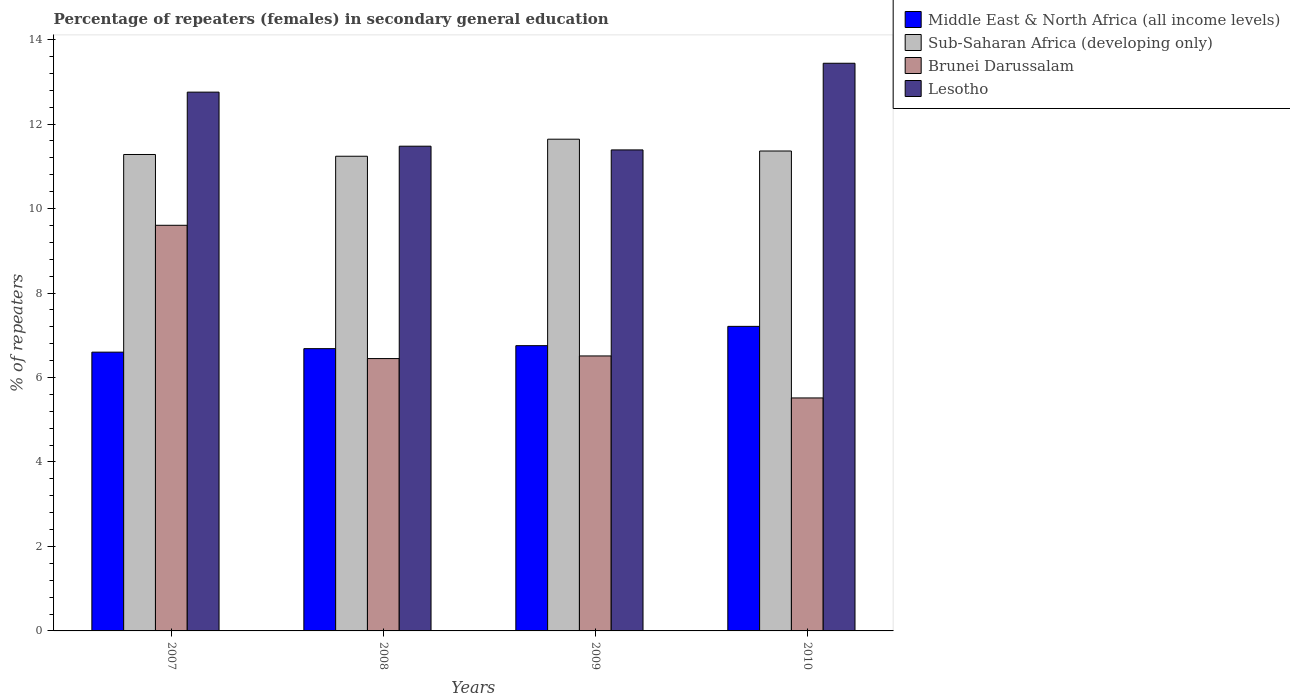How many different coloured bars are there?
Offer a terse response. 4. Are the number of bars per tick equal to the number of legend labels?
Provide a succinct answer. Yes. In how many cases, is the number of bars for a given year not equal to the number of legend labels?
Your answer should be very brief. 0. What is the percentage of female repeaters in Sub-Saharan Africa (developing only) in 2008?
Offer a terse response. 11.24. Across all years, what is the maximum percentage of female repeaters in Brunei Darussalam?
Offer a very short reply. 9.6. Across all years, what is the minimum percentage of female repeaters in Sub-Saharan Africa (developing only)?
Make the answer very short. 11.24. What is the total percentage of female repeaters in Lesotho in the graph?
Your answer should be very brief. 49.06. What is the difference between the percentage of female repeaters in Brunei Darussalam in 2008 and that in 2010?
Keep it short and to the point. 0.93. What is the difference between the percentage of female repeaters in Middle East & North Africa (all income levels) in 2008 and the percentage of female repeaters in Brunei Darussalam in 2010?
Your response must be concise. 1.17. What is the average percentage of female repeaters in Middle East & North Africa (all income levels) per year?
Make the answer very short. 6.81. In the year 2008, what is the difference between the percentage of female repeaters in Brunei Darussalam and percentage of female repeaters in Lesotho?
Give a very brief answer. -5.03. What is the ratio of the percentage of female repeaters in Sub-Saharan Africa (developing only) in 2007 to that in 2008?
Your response must be concise. 1. Is the difference between the percentage of female repeaters in Brunei Darussalam in 2008 and 2009 greater than the difference between the percentage of female repeaters in Lesotho in 2008 and 2009?
Offer a terse response. No. What is the difference between the highest and the second highest percentage of female repeaters in Middle East & North Africa (all income levels)?
Offer a terse response. 0.46. What is the difference between the highest and the lowest percentage of female repeaters in Middle East & North Africa (all income levels)?
Ensure brevity in your answer.  0.61. Is it the case that in every year, the sum of the percentage of female repeaters in Lesotho and percentage of female repeaters in Brunei Darussalam is greater than the sum of percentage of female repeaters in Middle East & North Africa (all income levels) and percentage of female repeaters in Sub-Saharan Africa (developing only)?
Offer a very short reply. No. What does the 3rd bar from the left in 2007 represents?
Offer a terse response. Brunei Darussalam. What does the 3rd bar from the right in 2007 represents?
Offer a very short reply. Sub-Saharan Africa (developing only). What is the difference between two consecutive major ticks on the Y-axis?
Provide a succinct answer. 2. Are the values on the major ticks of Y-axis written in scientific E-notation?
Keep it short and to the point. No. Does the graph contain any zero values?
Make the answer very short. No. Where does the legend appear in the graph?
Ensure brevity in your answer.  Top right. How many legend labels are there?
Keep it short and to the point. 4. What is the title of the graph?
Provide a short and direct response. Percentage of repeaters (females) in secondary general education. Does "India" appear as one of the legend labels in the graph?
Your response must be concise. No. What is the label or title of the X-axis?
Provide a succinct answer. Years. What is the label or title of the Y-axis?
Your answer should be very brief. % of repeaters. What is the % of repeaters of Middle East & North Africa (all income levels) in 2007?
Your response must be concise. 6.6. What is the % of repeaters in Sub-Saharan Africa (developing only) in 2007?
Your answer should be very brief. 11.28. What is the % of repeaters in Brunei Darussalam in 2007?
Your answer should be compact. 9.6. What is the % of repeaters of Lesotho in 2007?
Keep it short and to the point. 12.76. What is the % of repeaters in Middle East & North Africa (all income levels) in 2008?
Keep it short and to the point. 6.68. What is the % of repeaters of Sub-Saharan Africa (developing only) in 2008?
Provide a short and direct response. 11.24. What is the % of repeaters of Brunei Darussalam in 2008?
Keep it short and to the point. 6.45. What is the % of repeaters of Lesotho in 2008?
Give a very brief answer. 11.48. What is the % of repeaters of Middle East & North Africa (all income levels) in 2009?
Give a very brief answer. 6.75. What is the % of repeaters of Sub-Saharan Africa (developing only) in 2009?
Provide a succinct answer. 11.64. What is the % of repeaters in Brunei Darussalam in 2009?
Your response must be concise. 6.51. What is the % of repeaters in Lesotho in 2009?
Your answer should be very brief. 11.39. What is the % of repeaters of Middle East & North Africa (all income levels) in 2010?
Give a very brief answer. 7.21. What is the % of repeaters of Sub-Saharan Africa (developing only) in 2010?
Offer a very short reply. 11.36. What is the % of repeaters of Brunei Darussalam in 2010?
Your response must be concise. 5.52. What is the % of repeaters of Lesotho in 2010?
Provide a succinct answer. 13.44. Across all years, what is the maximum % of repeaters of Middle East & North Africa (all income levels)?
Ensure brevity in your answer.  7.21. Across all years, what is the maximum % of repeaters of Sub-Saharan Africa (developing only)?
Make the answer very short. 11.64. Across all years, what is the maximum % of repeaters of Brunei Darussalam?
Offer a terse response. 9.6. Across all years, what is the maximum % of repeaters in Lesotho?
Offer a very short reply. 13.44. Across all years, what is the minimum % of repeaters of Middle East & North Africa (all income levels)?
Give a very brief answer. 6.6. Across all years, what is the minimum % of repeaters of Sub-Saharan Africa (developing only)?
Provide a short and direct response. 11.24. Across all years, what is the minimum % of repeaters in Brunei Darussalam?
Provide a short and direct response. 5.52. Across all years, what is the minimum % of repeaters of Lesotho?
Your response must be concise. 11.39. What is the total % of repeaters in Middle East & North Africa (all income levels) in the graph?
Your answer should be compact. 27.25. What is the total % of repeaters in Sub-Saharan Africa (developing only) in the graph?
Provide a succinct answer. 45.52. What is the total % of repeaters of Brunei Darussalam in the graph?
Offer a terse response. 28.08. What is the total % of repeaters of Lesotho in the graph?
Ensure brevity in your answer.  49.06. What is the difference between the % of repeaters in Middle East & North Africa (all income levels) in 2007 and that in 2008?
Your response must be concise. -0.08. What is the difference between the % of repeaters in Sub-Saharan Africa (developing only) in 2007 and that in 2008?
Offer a terse response. 0.04. What is the difference between the % of repeaters in Brunei Darussalam in 2007 and that in 2008?
Give a very brief answer. 3.16. What is the difference between the % of repeaters of Lesotho in 2007 and that in 2008?
Provide a succinct answer. 1.28. What is the difference between the % of repeaters of Middle East & North Africa (all income levels) in 2007 and that in 2009?
Give a very brief answer. -0.15. What is the difference between the % of repeaters in Sub-Saharan Africa (developing only) in 2007 and that in 2009?
Offer a very short reply. -0.36. What is the difference between the % of repeaters of Brunei Darussalam in 2007 and that in 2009?
Offer a terse response. 3.09. What is the difference between the % of repeaters in Lesotho in 2007 and that in 2009?
Your response must be concise. 1.37. What is the difference between the % of repeaters of Middle East & North Africa (all income levels) in 2007 and that in 2010?
Your answer should be very brief. -0.61. What is the difference between the % of repeaters in Sub-Saharan Africa (developing only) in 2007 and that in 2010?
Offer a very short reply. -0.08. What is the difference between the % of repeaters in Brunei Darussalam in 2007 and that in 2010?
Keep it short and to the point. 4.09. What is the difference between the % of repeaters of Lesotho in 2007 and that in 2010?
Offer a very short reply. -0.68. What is the difference between the % of repeaters of Middle East & North Africa (all income levels) in 2008 and that in 2009?
Keep it short and to the point. -0.07. What is the difference between the % of repeaters of Sub-Saharan Africa (developing only) in 2008 and that in 2009?
Ensure brevity in your answer.  -0.4. What is the difference between the % of repeaters in Brunei Darussalam in 2008 and that in 2009?
Keep it short and to the point. -0.06. What is the difference between the % of repeaters of Lesotho in 2008 and that in 2009?
Make the answer very short. 0.09. What is the difference between the % of repeaters of Middle East & North Africa (all income levels) in 2008 and that in 2010?
Make the answer very short. -0.53. What is the difference between the % of repeaters of Sub-Saharan Africa (developing only) in 2008 and that in 2010?
Provide a succinct answer. -0.12. What is the difference between the % of repeaters of Brunei Darussalam in 2008 and that in 2010?
Provide a succinct answer. 0.93. What is the difference between the % of repeaters in Lesotho in 2008 and that in 2010?
Give a very brief answer. -1.96. What is the difference between the % of repeaters in Middle East & North Africa (all income levels) in 2009 and that in 2010?
Your response must be concise. -0.46. What is the difference between the % of repeaters in Sub-Saharan Africa (developing only) in 2009 and that in 2010?
Your answer should be compact. 0.28. What is the difference between the % of repeaters of Brunei Darussalam in 2009 and that in 2010?
Keep it short and to the point. 0.99. What is the difference between the % of repeaters in Lesotho in 2009 and that in 2010?
Your answer should be compact. -2.05. What is the difference between the % of repeaters of Middle East & North Africa (all income levels) in 2007 and the % of repeaters of Sub-Saharan Africa (developing only) in 2008?
Ensure brevity in your answer.  -4.64. What is the difference between the % of repeaters in Middle East & North Africa (all income levels) in 2007 and the % of repeaters in Brunei Darussalam in 2008?
Your response must be concise. 0.15. What is the difference between the % of repeaters in Middle East & North Africa (all income levels) in 2007 and the % of repeaters in Lesotho in 2008?
Offer a very short reply. -4.88. What is the difference between the % of repeaters of Sub-Saharan Africa (developing only) in 2007 and the % of repeaters of Brunei Darussalam in 2008?
Your answer should be very brief. 4.83. What is the difference between the % of repeaters of Sub-Saharan Africa (developing only) in 2007 and the % of repeaters of Lesotho in 2008?
Keep it short and to the point. -0.2. What is the difference between the % of repeaters of Brunei Darussalam in 2007 and the % of repeaters of Lesotho in 2008?
Offer a very short reply. -1.87. What is the difference between the % of repeaters of Middle East & North Africa (all income levels) in 2007 and the % of repeaters of Sub-Saharan Africa (developing only) in 2009?
Ensure brevity in your answer.  -5.04. What is the difference between the % of repeaters in Middle East & North Africa (all income levels) in 2007 and the % of repeaters in Brunei Darussalam in 2009?
Your answer should be very brief. 0.09. What is the difference between the % of repeaters of Middle East & North Africa (all income levels) in 2007 and the % of repeaters of Lesotho in 2009?
Provide a short and direct response. -4.79. What is the difference between the % of repeaters of Sub-Saharan Africa (developing only) in 2007 and the % of repeaters of Brunei Darussalam in 2009?
Your answer should be compact. 4.77. What is the difference between the % of repeaters of Sub-Saharan Africa (developing only) in 2007 and the % of repeaters of Lesotho in 2009?
Provide a short and direct response. -0.11. What is the difference between the % of repeaters of Brunei Darussalam in 2007 and the % of repeaters of Lesotho in 2009?
Your response must be concise. -1.78. What is the difference between the % of repeaters in Middle East & North Africa (all income levels) in 2007 and the % of repeaters in Sub-Saharan Africa (developing only) in 2010?
Your answer should be compact. -4.76. What is the difference between the % of repeaters in Middle East & North Africa (all income levels) in 2007 and the % of repeaters in Brunei Darussalam in 2010?
Give a very brief answer. 1.08. What is the difference between the % of repeaters of Middle East & North Africa (all income levels) in 2007 and the % of repeaters of Lesotho in 2010?
Make the answer very short. -6.84. What is the difference between the % of repeaters in Sub-Saharan Africa (developing only) in 2007 and the % of repeaters in Brunei Darussalam in 2010?
Keep it short and to the point. 5.76. What is the difference between the % of repeaters of Sub-Saharan Africa (developing only) in 2007 and the % of repeaters of Lesotho in 2010?
Give a very brief answer. -2.16. What is the difference between the % of repeaters in Brunei Darussalam in 2007 and the % of repeaters in Lesotho in 2010?
Your answer should be very brief. -3.84. What is the difference between the % of repeaters of Middle East & North Africa (all income levels) in 2008 and the % of repeaters of Sub-Saharan Africa (developing only) in 2009?
Offer a very short reply. -4.96. What is the difference between the % of repeaters of Middle East & North Africa (all income levels) in 2008 and the % of repeaters of Brunei Darussalam in 2009?
Your answer should be compact. 0.17. What is the difference between the % of repeaters in Middle East & North Africa (all income levels) in 2008 and the % of repeaters in Lesotho in 2009?
Provide a succinct answer. -4.71. What is the difference between the % of repeaters in Sub-Saharan Africa (developing only) in 2008 and the % of repeaters in Brunei Darussalam in 2009?
Provide a succinct answer. 4.73. What is the difference between the % of repeaters of Sub-Saharan Africa (developing only) in 2008 and the % of repeaters of Lesotho in 2009?
Provide a short and direct response. -0.15. What is the difference between the % of repeaters of Brunei Darussalam in 2008 and the % of repeaters of Lesotho in 2009?
Your answer should be compact. -4.94. What is the difference between the % of repeaters in Middle East & North Africa (all income levels) in 2008 and the % of repeaters in Sub-Saharan Africa (developing only) in 2010?
Your answer should be very brief. -4.68. What is the difference between the % of repeaters in Middle East & North Africa (all income levels) in 2008 and the % of repeaters in Brunei Darussalam in 2010?
Offer a very short reply. 1.17. What is the difference between the % of repeaters in Middle East & North Africa (all income levels) in 2008 and the % of repeaters in Lesotho in 2010?
Ensure brevity in your answer.  -6.76. What is the difference between the % of repeaters of Sub-Saharan Africa (developing only) in 2008 and the % of repeaters of Brunei Darussalam in 2010?
Your response must be concise. 5.72. What is the difference between the % of repeaters of Sub-Saharan Africa (developing only) in 2008 and the % of repeaters of Lesotho in 2010?
Make the answer very short. -2.2. What is the difference between the % of repeaters in Brunei Darussalam in 2008 and the % of repeaters in Lesotho in 2010?
Make the answer very short. -6.99. What is the difference between the % of repeaters of Middle East & North Africa (all income levels) in 2009 and the % of repeaters of Sub-Saharan Africa (developing only) in 2010?
Provide a succinct answer. -4.61. What is the difference between the % of repeaters in Middle East & North Africa (all income levels) in 2009 and the % of repeaters in Brunei Darussalam in 2010?
Make the answer very short. 1.24. What is the difference between the % of repeaters of Middle East & North Africa (all income levels) in 2009 and the % of repeaters of Lesotho in 2010?
Ensure brevity in your answer.  -6.69. What is the difference between the % of repeaters in Sub-Saharan Africa (developing only) in 2009 and the % of repeaters in Brunei Darussalam in 2010?
Your answer should be compact. 6.13. What is the difference between the % of repeaters in Sub-Saharan Africa (developing only) in 2009 and the % of repeaters in Lesotho in 2010?
Provide a short and direct response. -1.8. What is the difference between the % of repeaters of Brunei Darussalam in 2009 and the % of repeaters of Lesotho in 2010?
Provide a succinct answer. -6.93. What is the average % of repeaters of Middle East & North Africa (all income levels) per year?
Make the answer very short. 6.81. What is the average % of repeaters of Sub-Saharan Africa (developing only) per year?
Make the answer very short. 11.38. What is the average % of repeaters of Brunei Darussalam per year?
Provide a succinct answer. 7.02. What is the average % of repeaters in Lesotho per year?
Give a very brief answer. 12.27. In the year 2007, what is the difference between the % of repeaters of Middle East & North Africa (all income levels) and % of repeaters of Sub-Saharan Africa (developing only)?
Your response must be concise. -4.68. In the year 2007, what is the difference between the % of repeaters of Middle East & North Africa (all income levels) and % of repeaters of Brunei Darussalam?
Offer a terse response. -3. In the year 2007, what is the difference between the % of repeaters of Middle East & North Africa (all income levels) and % of repeaters of Lesotho?
Offer a very short reply. -6.16. In the year 2007, what is the difference between the % of repeaters of Sub-Saharan Africa (developing only) and % of repeaters of Brunei Darussalam?
Make the answer very short. 1.68. In the year 2007, what is the difference between the % of repeaters in Sub-Saharan Africa (developing only) and % of repeaters in Lesotho?
Your answer should be compact. -1.48. In the year 2007, what is the difference between the % of repeaters of Brunei Darussalam and % of repeaters of Lesotho?
Provide a short and direct response. -3.15. In the year 2008, what is the difference between the % of repeaters of Middle East & North Africa (all income levels) and % of repeaters of Sub-Saharan Africa (developing only)?
Ensure brevity in your answer.  -4.56. In the year 2008, what is the difference between the % of repeaters in Middle East & North Africa (all income levels) and % of repeaters in Brunei Darussalam?
Provide a succinct answer. 0.23. In the year 2008, what is the difference between the % of repeaters in Middle East & North Africa (all income levels) and % of repeaters in Lesotho?
Your answer should be very brief. -4.79. In the year 2008, what is the difference between the % of repeaters in Sub-Saharan Africa (developing only) and % of repeaters in Brunei Darussalam?
Offer a terse response. 4.79. In the year 2008, what is the difference between the % of repeaters in Sub-Saharan Africa (developing only) and % of repeaters in Lesotho?
Provide a succinct answer. -0.24. In the year 2008, what is the difference between the % of repeaters in Brunei Darussalam and % of repeaters in Lesotho?
Provide a succinct answer. -5.03. In the year 2009, what is the difference between the % of repeaters in Middle East & North Africa (all income levels) and % of repeaters in Sub-Saharan Africa (developing only)?
Keep it short and to the point. -4.89. In the year 2009, what is the difference between the % of repeaters of Middle East & North Africa (all income levels) and % of repeaters of Brunei Darussalam?
Your answer should be compact. 0.24. In the year 2009, what is the difference between the % of repeaters of Middle East & North Africa (all income levels) and % of repeaters of Lesotho?
Your answer should be very brief. -4.63. In the year 2009, what is the difference between the % of repeaters in Sub-Saharan Africa (developing only) and % of repeaters in Brunei Darussalam?
Your answer should be compact. 5.13. In the year 2009, what is the difference between the % of repeaters in Sub-Saharan Africa (developing only) and % of repeaters in Lesotho?
Your answer should be compact. 0.25. In the year 2009, what is the difference between the % of repeaters of Brunei Darussalam and % of repeaters of Lesotho?
Your response must be concise. -4.88. In the year 2010, what is the difference between the % of repeaters in Middle East & North Africa (all income levels) and % of repeaters in Sub-Saharan Africa (developing only)?
Give a very brief answer. -4.15. In the year 2010, what is the difference between the % of repeaters in Middle East & North Africa (all income levels) and % of repeaters in Brunei Darussalam?
Your response must be concise. 1.69. In the year 2010, what is the difference between the % of repeaters in Middle East & North Africa (all income levels) and % of repeaters in Lesotho?
Provide a succinct answer. -6.23. In the year 2010, what is the difference between the % of repeaters of Sub-Saharan Africa (developing only) and % of repeaters of Brunei Darussalam?
Make the answer very short. 5.85. In the year 2010, what is the difference between the % of repeaters in Sub-Saharan Africa (developing only) and % of repeaters in Lesotho?
Your answer should be compact. -2.08. In the year 2010, what is the difference between the % of repeaters in Brunei Darussalam and % of repeaters in Lesotho?
Provide a short and direct response. -7.92. What is the ratio of the % of repeaters of Middle East & North Africa (all income levels) in 2007 to that in 2008?
Offer a very short reply. 0.99. What is the ratio of the % of repeaters of Brunei Darussalam in 2007 to that in 2008?
Give a very brief answer. 1.49. What is the ratio of the % of repeaters of Lesotho in 2007 to that in 2008?
Your response must be concise. 1.11. What is the ratio of the % of repeaters in Middle East & North Africa (all income levels) in 2007 to that in 2009?
Keep it short and to the point. 0.98. What is the ratio of the % of repeaters in Sub-Saharan Africa (developing only) in 2007 to that in 2009?
Your answer should be compact. 0.97. What is the ratio of the % of repeaters in Brunei Darussalam in 2007 to that in 2009?
Keep it short and to the point. 1.48. What is the ratio of the % of repeaters of Lesotho in 2007 to that in 2009?
Provide a succinct answer. 1.12. What is the ratio of the % of repeaters of Middle East & North Africa (all income levels) in 2007 to that in 2010?
Provide a short and direct response. 0.92. What is the ratio of the % of repeaters in Sub-Saharan Africa (developing only) in 2007 to that in 2010?
Your response must be concise. 0.99. What is the ratio of the % of repeaters in Brunei Darussalam in 2007 to that in 2010?
Provide a succinct answer. 1.74. What is the ratio of the % of repeaters of Lesotho in 2007 to that in 2010?
Make the answer very short. 0.95. What is the ratio of the % of repeaters in Sub-Saharan Africa (developing only) in 2008 to that in 2009?
Offer a very short reply. 0.97. What is the ratio of the % of repeaters of Brunei Darussalam in 2008 to that in 2009?
Provide a short and direct response. 0.99. What is the ratio of the % of repeaters of Lesotho in 2008 to that in 2009?
Your answer should be compact. 1.01. What is the ratio of the % of repeaters of Middle East & North Africa (all income levels) in 2008 to that in 2010?
Give a very brief answer. 0.93. What is the ratio of the % of repeaters in Sub-Saharan Africa (developing only) in 2008 to that in 2010?
Your answer should be very brief. 0.99. What is the ratio of the % of repeaters of Brunei Darussalam in 2008 to that in 2010?
Offer a very short reply. 1.17. What is the ratio of the % of repeaters of Lesotho in 2008 to that in 2010?
Provide a short and direct response. 0.85. What is the ratio of the % of repeaters in Middle East & North Africa (all income levels) in 2009 to that in 2010?
Ensure brevity in your answer.  0.94. What is the ratio of the % of repeaters in Sub-Saharan Africa (developing only) in 2009 to that in 2010?
Make the answer very short. 1.02. What is the ratio of the % of repeaters in Brunei Darussalam in 2009 to that in 2010?
Offer a very short reply. 1.18. What is the ratio of the % of repeaters of Lesotho in 2009 to that in 2010?
Your answer should be very brief. 0.85. What is the difference between the highest and the second highest % of repeaters of Middle East & North Africa (all income levels)?
Your answer should be very brief. 0.46. What is the difference between the highest and the second highest % of repeaters in Sub-Saharan Africa (developing only)?
Provide a short and direct response. 0.28. What is the difference between the highest and the second highest % of repeaters in Brunei Darussalam?
Offer a very short reply. 3.09. What is the difference between the highest and the second highest % of repeaters in Lesotho?
Provide a succinct answer. 0.68. What is the difference between the highest and the lowest % of repeaters in Middle East & North Africa (all income levels)?
Give a very brief answer. 0.61. What is the difference between the highest and the lowest % of repeaters of Sub-Saharan Africa (developing only)?
Offer a very short reply. 0.4. What is the difference between the highest and the lowest % of repeaters of Brunei Darussalam?
Your answer should be very brief. 4.09. What is the difference between the highest and the lowest % of repeaters of Lesotho?
Give a very brief answer. 2.05. 